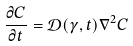Convert formula to latex. <formula><loc_0><loc_0><loc_500><loc_500>\frac { \partial C } { \partial t } = { \mathcal { D } } ( \gamma , t ) \nabla ^ { 2 } C</formula> 